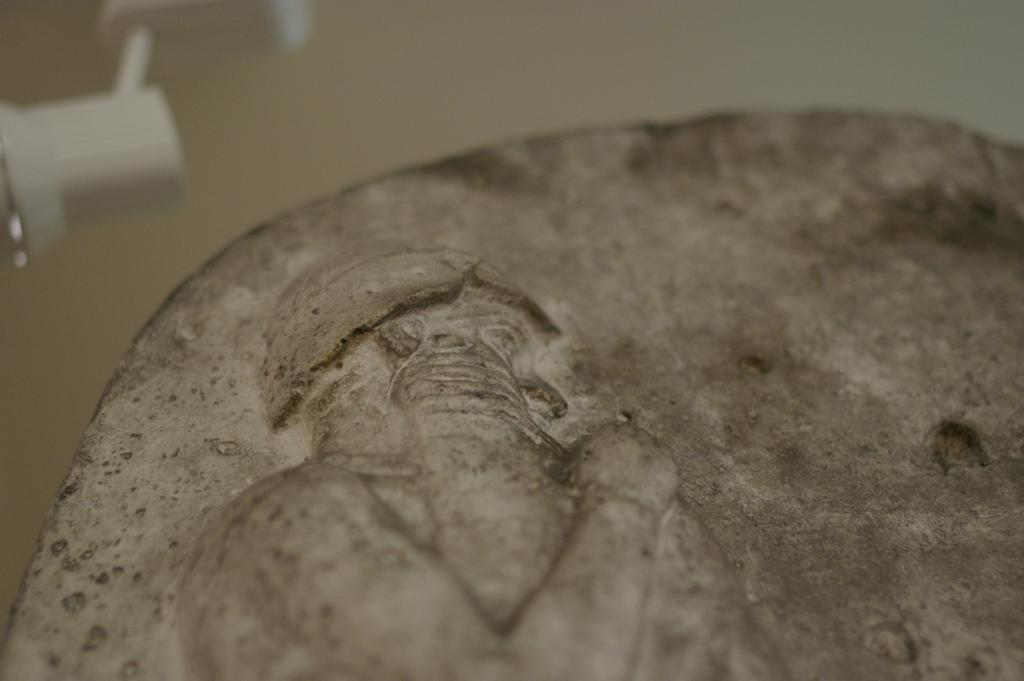What is the main subject of the image? The main subject of the image is a stone with carving. What is the color of the object in the image? There is a white color object in the image. How would you describe the background of the image? The background of the image is blurry. What type of authority figure can be seen in the image? There is no authority figure present in the image; it features a stone with carving and a white object. How does the tramp interact with the rail in the image? There is no tramp or rail present in the image. 